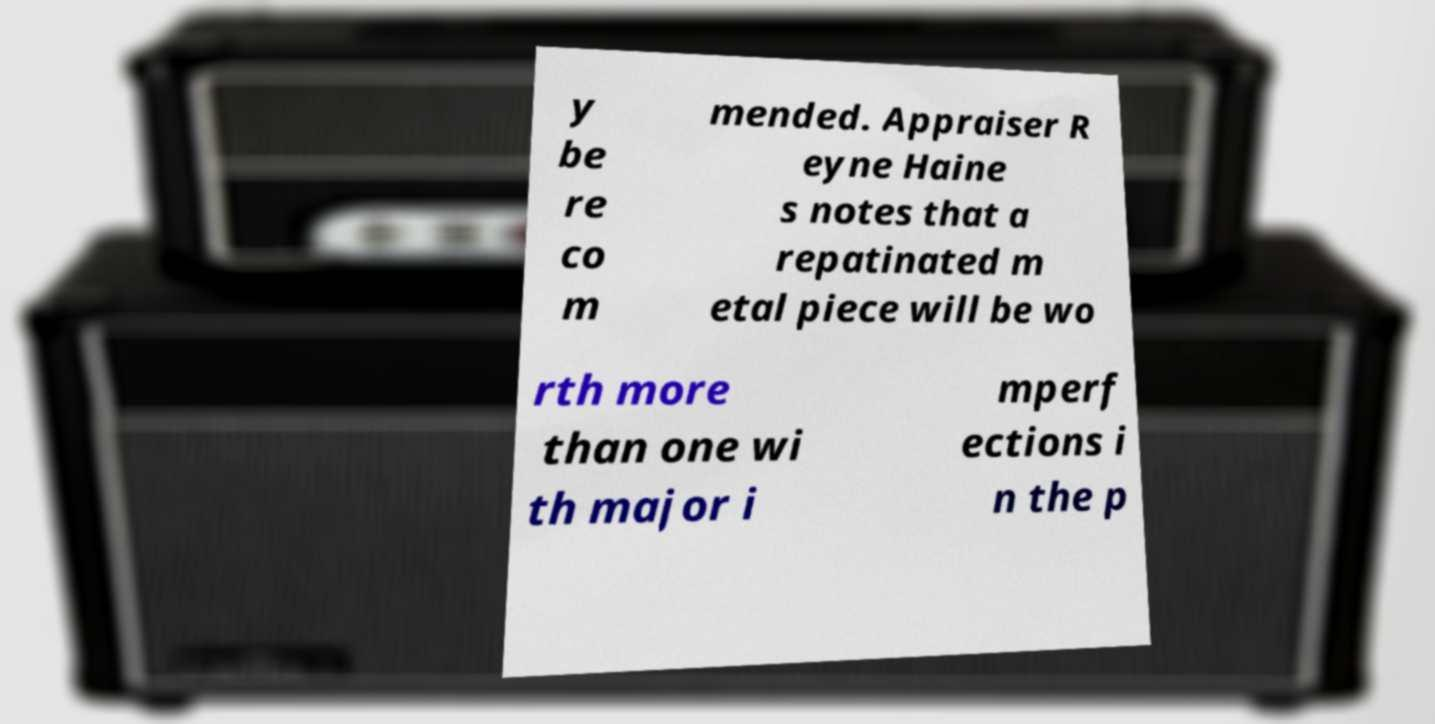Can you accurately transcribe the text from the provided image for me? y be re co m mended. Appraiser R eyne Haine s notes that a repatinated m etal piece will be wo rth more than one wi th major i mperf ections i n the p 